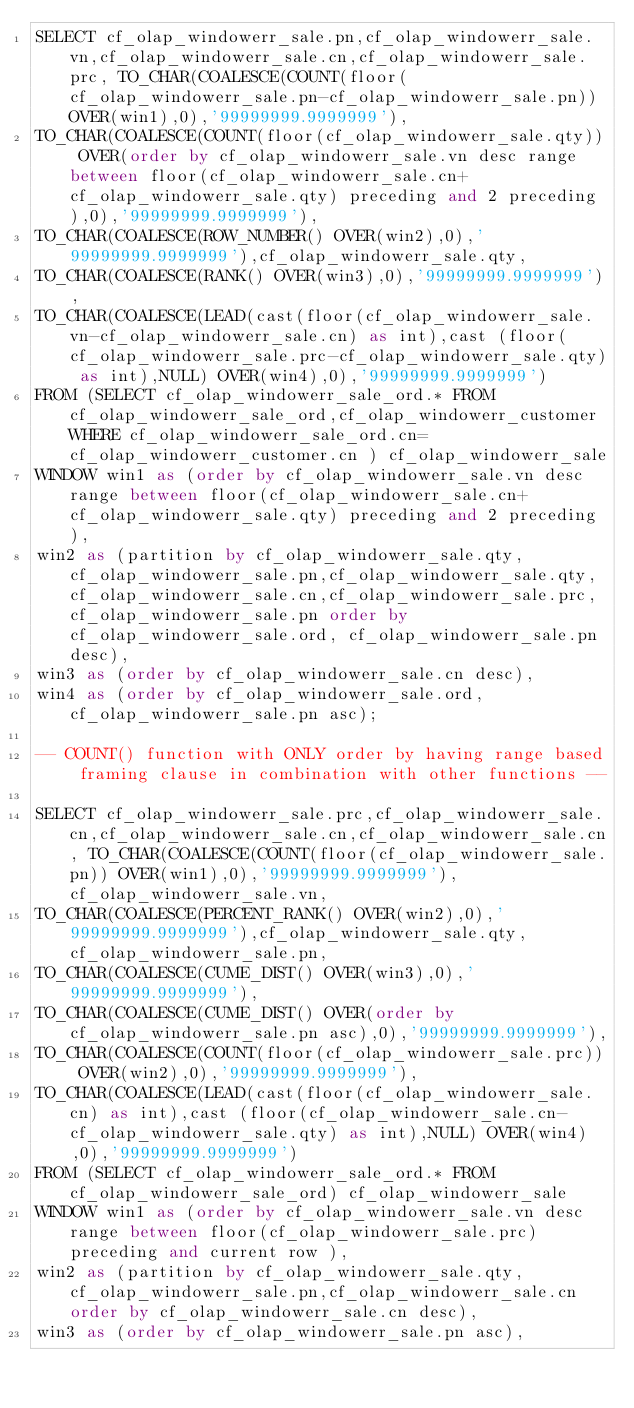Convert code to text. <code><loc_0><loc_0><loc_500><loc_500><_SQL_>SELECT cf_olap_windowerr_sale.pn,cf_olap_windowerr_sale.vn,cf_olap_windowerr_sale.cn,cf_olap_windowerr_sale.prc, TO_CHAR(COALESCE(COUNT(floor(cf_olap_windowerr_sale.pn-cf_olap_windowerr_sale.pn)) OVER(win1),0),'99999999.9999999'),
TO_CHAR(COALESCE(COUNT(floor(cf_olap_windowerr_sale.qty)) OVER(order by cf_olap_windowerr_sale.vn desc range between floor(cf_olap_windowerr_sale.cn+cf_olap_windowerr_sale.qty) preceding and 2 preceding ),0),'99999999.9999999'),
TO_CHAR(COALESCE(ROW_NUMBER() OVER(win2),0),'99999999.9999999'),cf_olap_windowerr_sale.qty,
TO_CHAR(COALESCE(RANK() OVER(win3),0),'99999999.9999999'),
TO_CHAR(COALESCE(LEAD(cast(floor(cf_olap_windowerr_sale.vn-cf_olap_windowerr_sale.cn) as int),cast (floor(cf_olap_windowerr_sale.prc-cf_olap_windowerr_sale.qty) as int),NULL) OVER(win4),0),'99999999.9999999')
FROM (SELECT cf_olap_windowerr_sale_ord.* FROM cf_olap_windowerr_sale_ord,cf_olap_windowerr_customer WHERE cf_olap_windowerr_sale_ord.cn=cf_olap_windowerr_customer.cn ) cf_olap_windowerr_sale
WINDOW win1 as (order by cf_olap_windowerr_sale.vn desc range between floor(cf_olap_windowerr_sale.cn+cf_olap_windowerr_sale.qty) preceding and 2 preceding ),
win2 as (partition by cf_olap_windowerr_sale.qty,cf_olap_windowerr_sale.pn,cf_olap_windowerr_sale.qty,cf_olap_windowerr_sale.cn,cf_olap_windowerr_sale.prc,cf_olap_windowerr_sale.pn order by cf_olap_windowerr_sale.ord, cf_olap_windowerr_sale.pn desc),
win3 as (order by cf_olap_windowerr_sale.cn desc),
win4 as (order by cf_olap_windowerr_sale.ord, cf_olap_windowerr_sale.pn asc);

-- COUNT() function with ONLY order by having range based framing clause in combination with other functions --

SELECT cf_olap_windowerr_sale.prc,cf_olap_windowerr_sale.cn,cf_olap_windowerr_sale.cn,cf_olap_windowerr_sale.cn, TO_CHAR(COALESCE(COUNT(floor(cf_olap_windowerr_sale.pn)) OVER(win1),0),'99999999.9999999'),cf_olap_windowerr_sale.vn,
TO_CHAR(COALESCE(PERCENT_RANK() OVER(win2),0),'99999999.9999999'),cf_olap_windowerr_sale.qty,cf_olap_windowerr_sale.pn,
TO_CHAR(COALESCE(CUME_DIST() OVER(win3),0),'99999999.9999999'),
TO_CHAR(COALESCE(CUME_DIST() OVER(order by cf_olap_windowerr_sale.pn asc),0),'99999999.9999999'),
TO_CHAR(COALESCE(COUNT(floor(cf_olap_windowerr_sale.prc)) OVER(win2),0),'99999999.9999999'),
TO_CHAR(COALESCE(LEAD(cast(floor(cf_olap_windowerr_sale.cn) as int),cast (floor(cf_olap_windowerr_sale.cn-cf_olap_windowerr_sale.qty) as int),NULL) OVER(win4),0),'99999999.9999999')
FROM (SELECT cf_olap_windowerr_sale_ord.* FROM cf_olap_windowerr_sale_ord) cf_olap_windowerr_sale
WINDOW win1 as (order by cf_olap_windowerr_sale.vn desc range between floor(cf_olap_windowerr_sale.prc) preceding and current row ),
win2 as (partition by cf_olap_windowerr_sale.qty,cf_olap_windowerr_sale.pn,cf_olap_windowerr_sale.cn order by cf_olap_windowerr_sale.cn desc),
win3 as (order by cf_olap_windowerr_sale.pn asc),</code> 